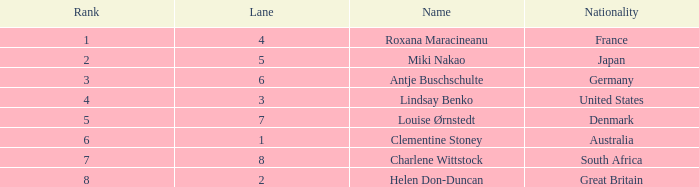What is the average Rank for a lane smaller than 3 with a nationality of Australia? 6.0. 